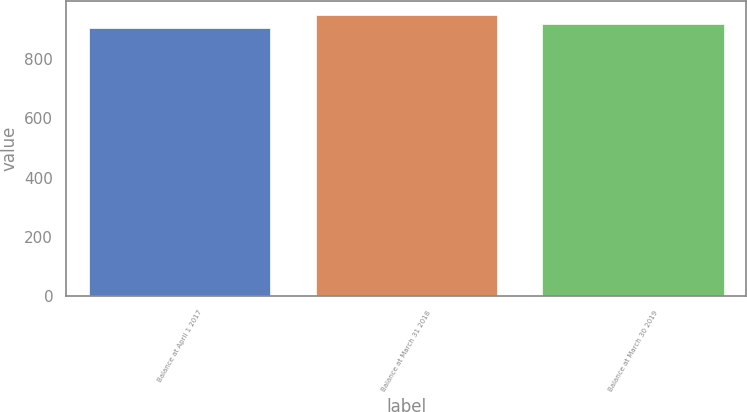Convert chart. <chart><loc_0><loc_0><loc_500><loc_500><bar_chart><fcel>Balance at April 1 2017<fcel>Balance at March 31 2018<fcel>Balance at March 30 2019<nl><fcel>904.6<fcel>950.5<fcel>919.6<nl></chart> 